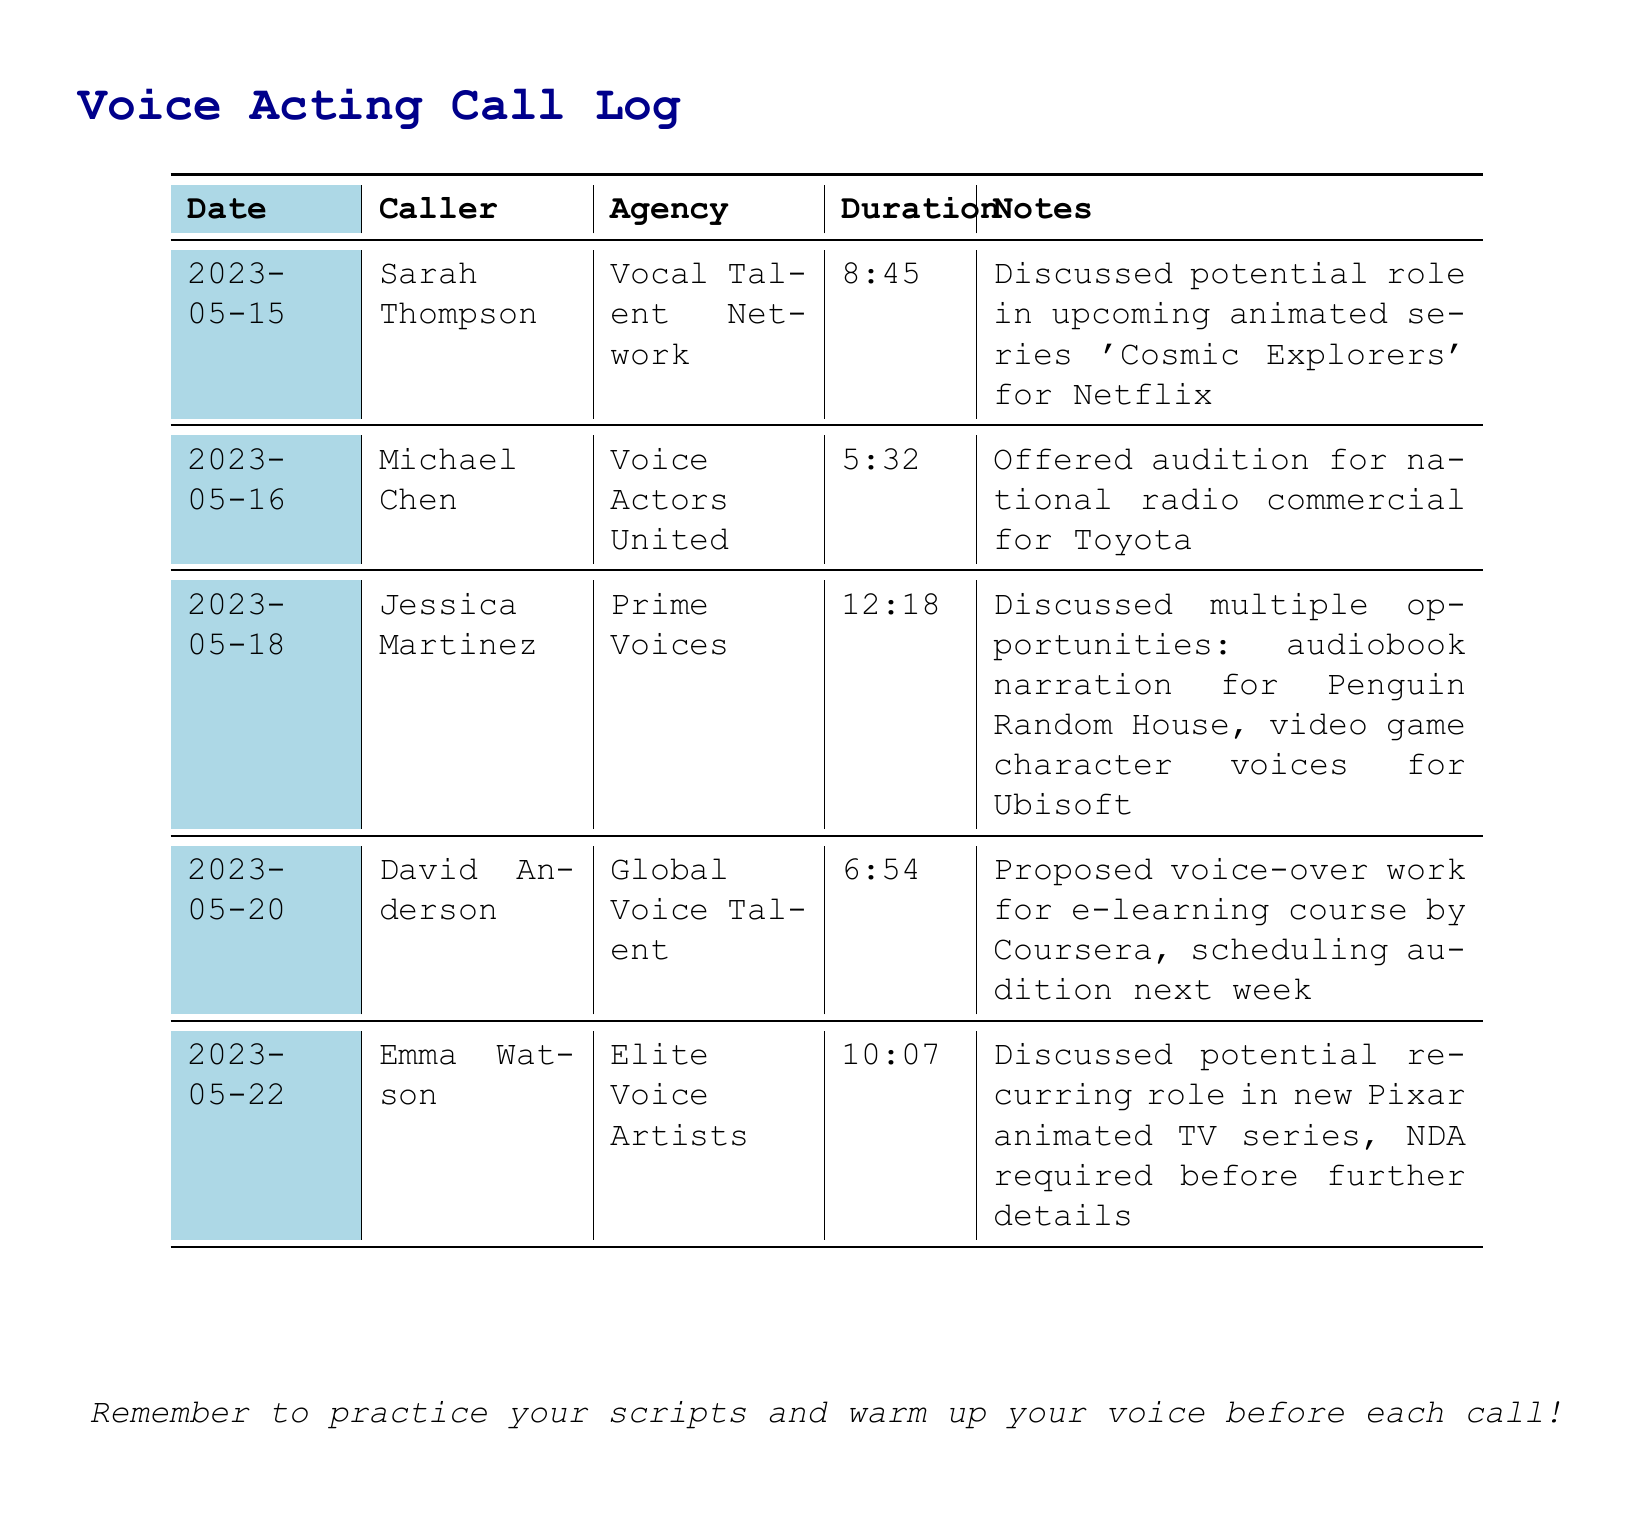What is the date of the earliest call? The earliest call is listed with a date of 2023-05-15.
Answer: 2023-05-15 Who called on May 16? The caller on May 16 is Michael Chen.
Answer: Michael Chen Which agency is associated with the opportunity for audiobook narration? Jessica Martinez discussed audiobook narration for Penguin Random House with Prime Voices.
Answer: Prime Voices What is the duration of the call from Emma Watson? The duration of the call from Emma Watson is 10 minutes and 7 seconds.
Answer: 10:07 How many opportunities were discussed by Jessica Martinez? Jessica Martinez discussed multiple opportunities during her call.
Answer: multiple opportunities Which company is mentioned for the national radio commercial? The national radio commercial is for Toyota, mentioned during Michael Chen's call.
Answer: Toyota What is the proposed work mentioned by David Anderson? David Anderson proposed voice-over work for an e-learning course.
Answer: voice-over work for e-learning course Is a Non-Disclosure Agreement required for the opportunity discussed with Emma Watson? Yes, an NDA is required before further details can be shared about the opportunity with Emma Watson.
Answer: NDA required What upcoming animated series was mentioned in relation to Sarah Thompson? Sarah Thompson discussed the upcoming animated series 'Cosmic Explorers' during her call.
Answer: 'Cosmic Explorers' 